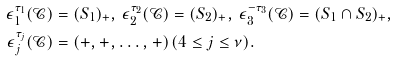<formula> <loc_0><loc_0><loc_500><loc_500>\epsilon _ { 1 } ^ { \tau _ { 1 } } ( \mathcal { C } ) & = ( S _ { 1 } ) _ { + } , \, \epsilon _ { 2 } ^ { \tau _ { 2 } } ( \mathcal { C } ) = ( S _ { 2 } ) _ { + } , \, \epsilon _ { 3 } ^ { - \tau _ { 3 } } ( \mathcal { C } ) = ( S _ { 1 } \cap S _ { 2 } ) _ { + } , \\ \epsilon _ { j } ^ { \tau _ { j } } ( \mathcal { C } ) & = ( + , + , \dots , + ) \, ( 4 \leq j \leq \nu ) .</formula> 